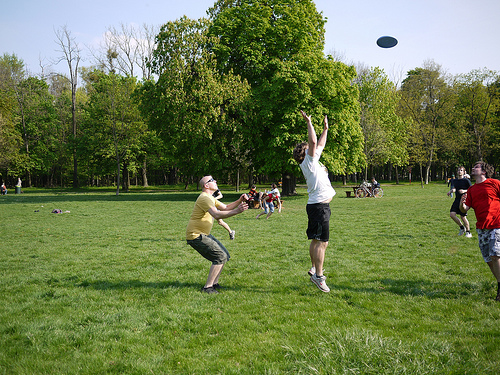Is the man that is to the right of the bench looking at forward? No, the man to the right of the bench is looking up towards the sky. 